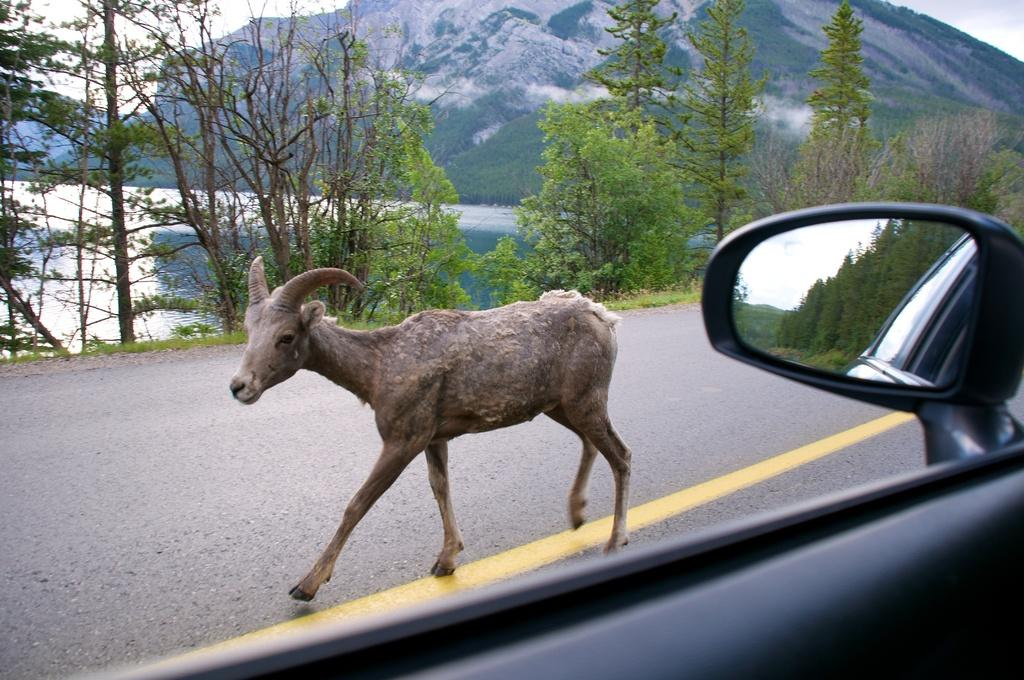What is on the road in the image? There is an animal on the road in the image. What object related to a vehicle can be seen in the image? There is a mirror to a vehicle in the image. What type of natural scenery is visible in the background of the image? There are trees, hills, and water visible in the background of the image. What type of dinner is being served on the hill in the image? There is no dinner or hill present in the image. 